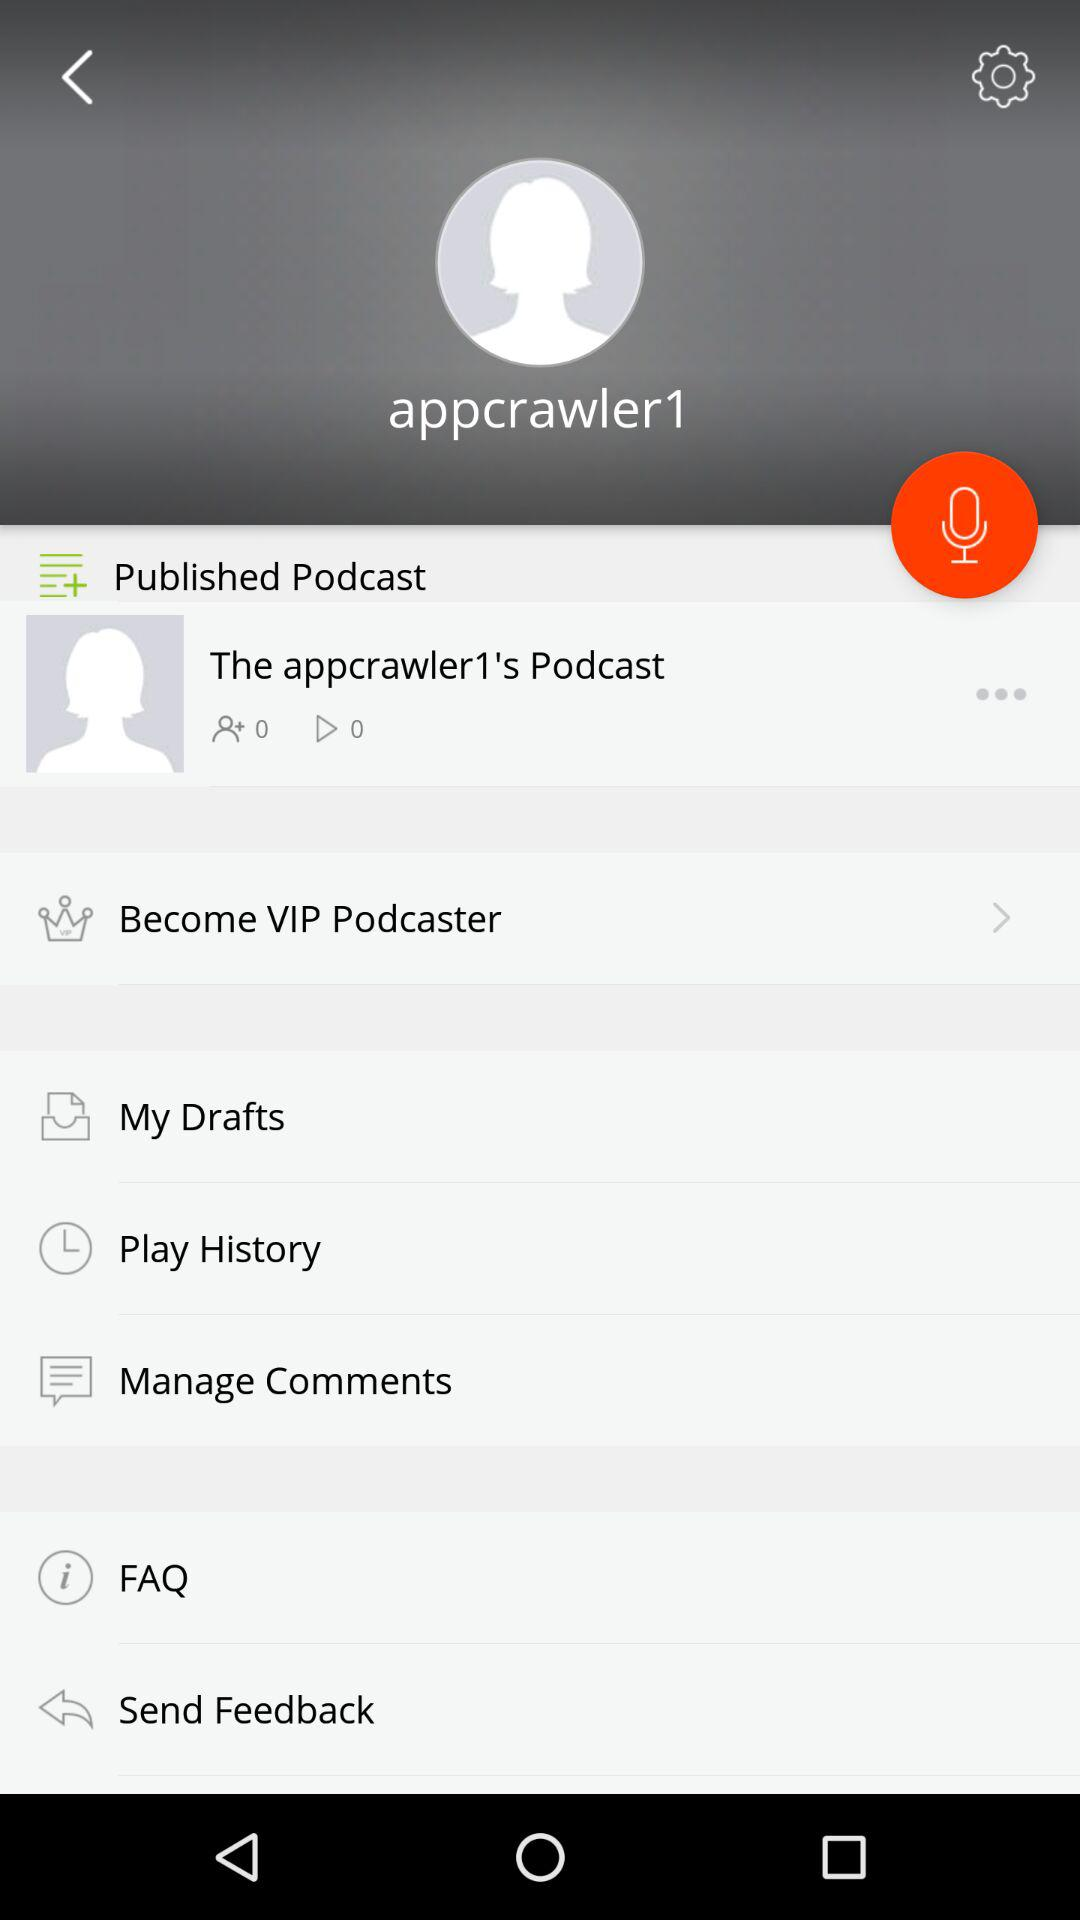How many times has the podcast been played? The podcast has been played 0 times. 